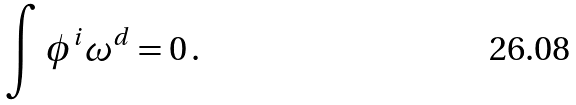<formula> <loc_0><loc_0><loc_500><loc_500>\int \phi ^ { i } \omega ^ { d } = 0 \, .</formula> 